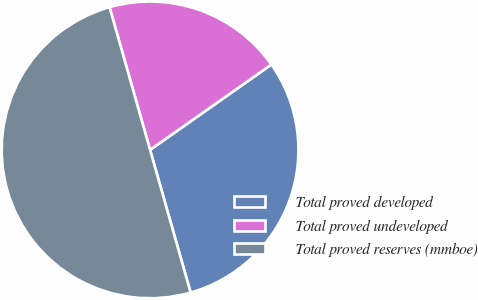Convert chart to OTSL. <chart><loc_0><loc_0><loc_500><loc_500><pie_chart><fcel>Total proved developed<fcel>Total proved undeveloped<fcel>Total proved reserves (mmboe)<nl><fcel>30.35%<fcel>19.65%<fcel>50.0%<nl></chart> 